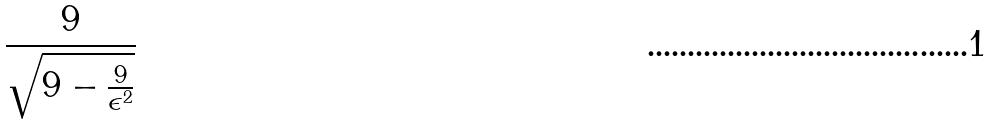Convert formula to latex. <formula><loc_0><loc_0><loc_500><loc_500>\frac { 9 } { \sqrt { 9 - \frac { 9 } { \epsilon ^ { 2 } } } }</formula> 